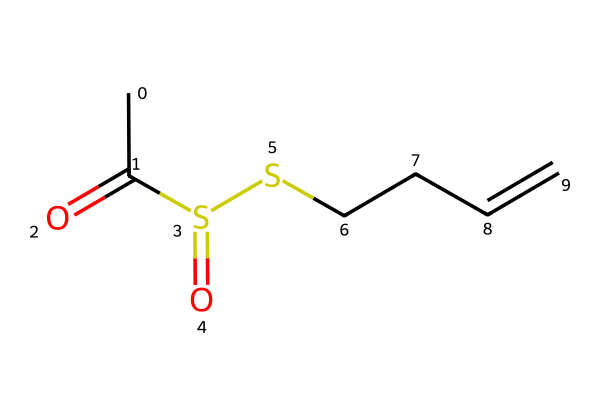What is the molecular formula of allicin based on its structure? By analyzing the elements in the chemical structure rendered by the SMILES representation, we can count the total number of each type of atom present. The structure shows 6 carbons (C), 10 hydrogens (H), 2 oxygens (O), and 2 sulfurs (S), leading to the molecular formula C6H10O2S2.
Answer: C6H10O2S2 How many sulfur atoms are present in the chemical structure? Looking at the structure, we can identify the sulfur atoms by counting the 'S' symbols in the SMILES. There are two 'S' symbols, indicating that there are two sulfur atoms in this compound.
Answer: 2 Which functional group is indicated by the presence of the "CC(=O)" in the structure? The "CC(=O)" portion of the SMILES suggests the presence of a carbonyl group (C=O) attached to a carbon chain, indicating that an acetyl (or acyl) functional group is present in the molecule.
Answer: acetyl What is the number of double bonds present in the molecule? By examining the structure, we can note that there is one double bond represented by the "C=C" part of the SMILES, indicating the presence of one double bond in the compound.
Answer: 1 Does this compound have potential antibacterial properties? Based on existing research on allicin, it is widely regarded for its antibacterial properties, especially against a range of bacteria due to the presence of sulfur in its structure which contributes to its reactivity.
Answer: Yes 